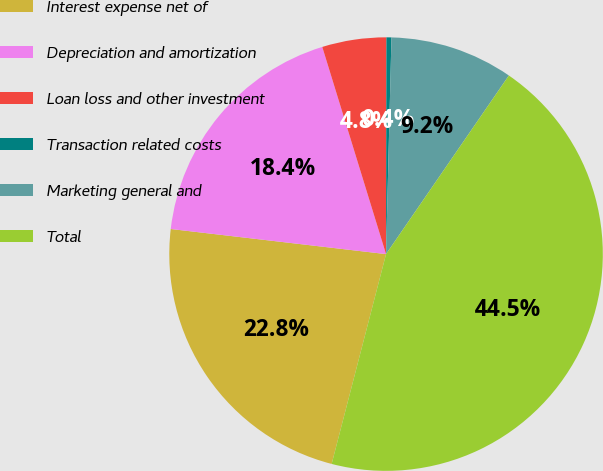Convert chart to OTSL. <chart><loc_0><loc_0><loc_500><loc_500><pie_chart><fcel>Interest expense net of<fcel>Depreciation and amortization<fcel>Loan loss and other investment<fcel>Transaction related costs<fcel>Marketing general and<fcel>Total<nl><fcel>22.81%<fcel>18.4%<fcel>4.78%<fcel>0.37%<fcel>9.19%<fcel>44.45%<nl></chart> 